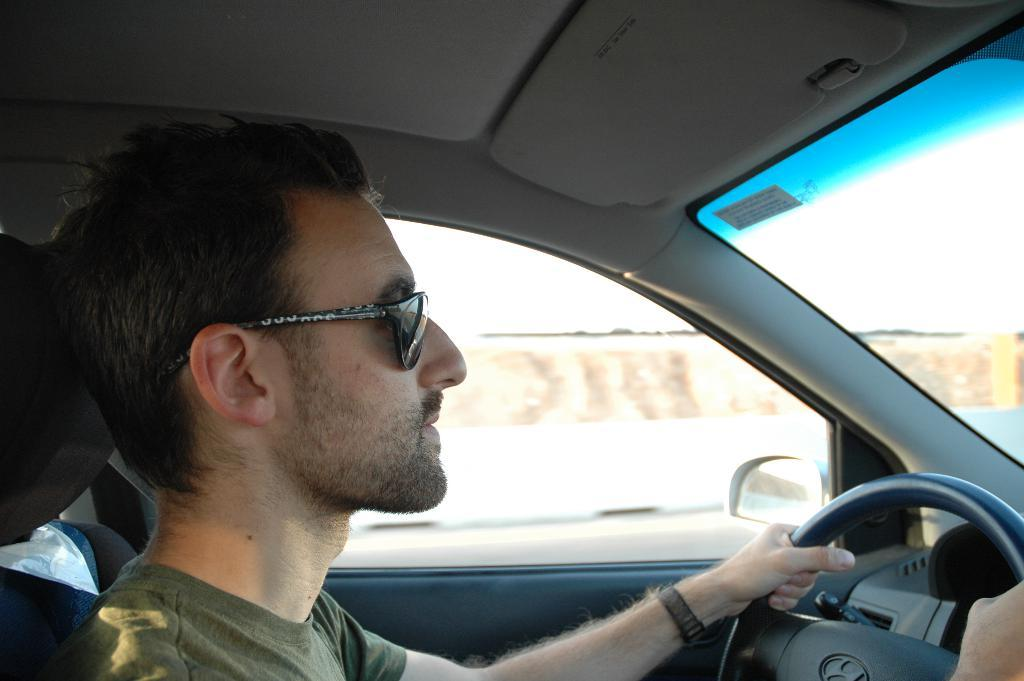Who is present in the image? There is a person in the image. What is the person wearing that covers their eyes? The person is wearing shades. What is the person holding in the image? The person is holding the steering wheel. Where is the person sitting in the image? The person is sitting in a car. What type of crib is visible in the image? There is no crib present in the image. How does the person manage to work while driving in the image? The person is not working in the image; they are simply holding the steering wheel while sitting in a car. 